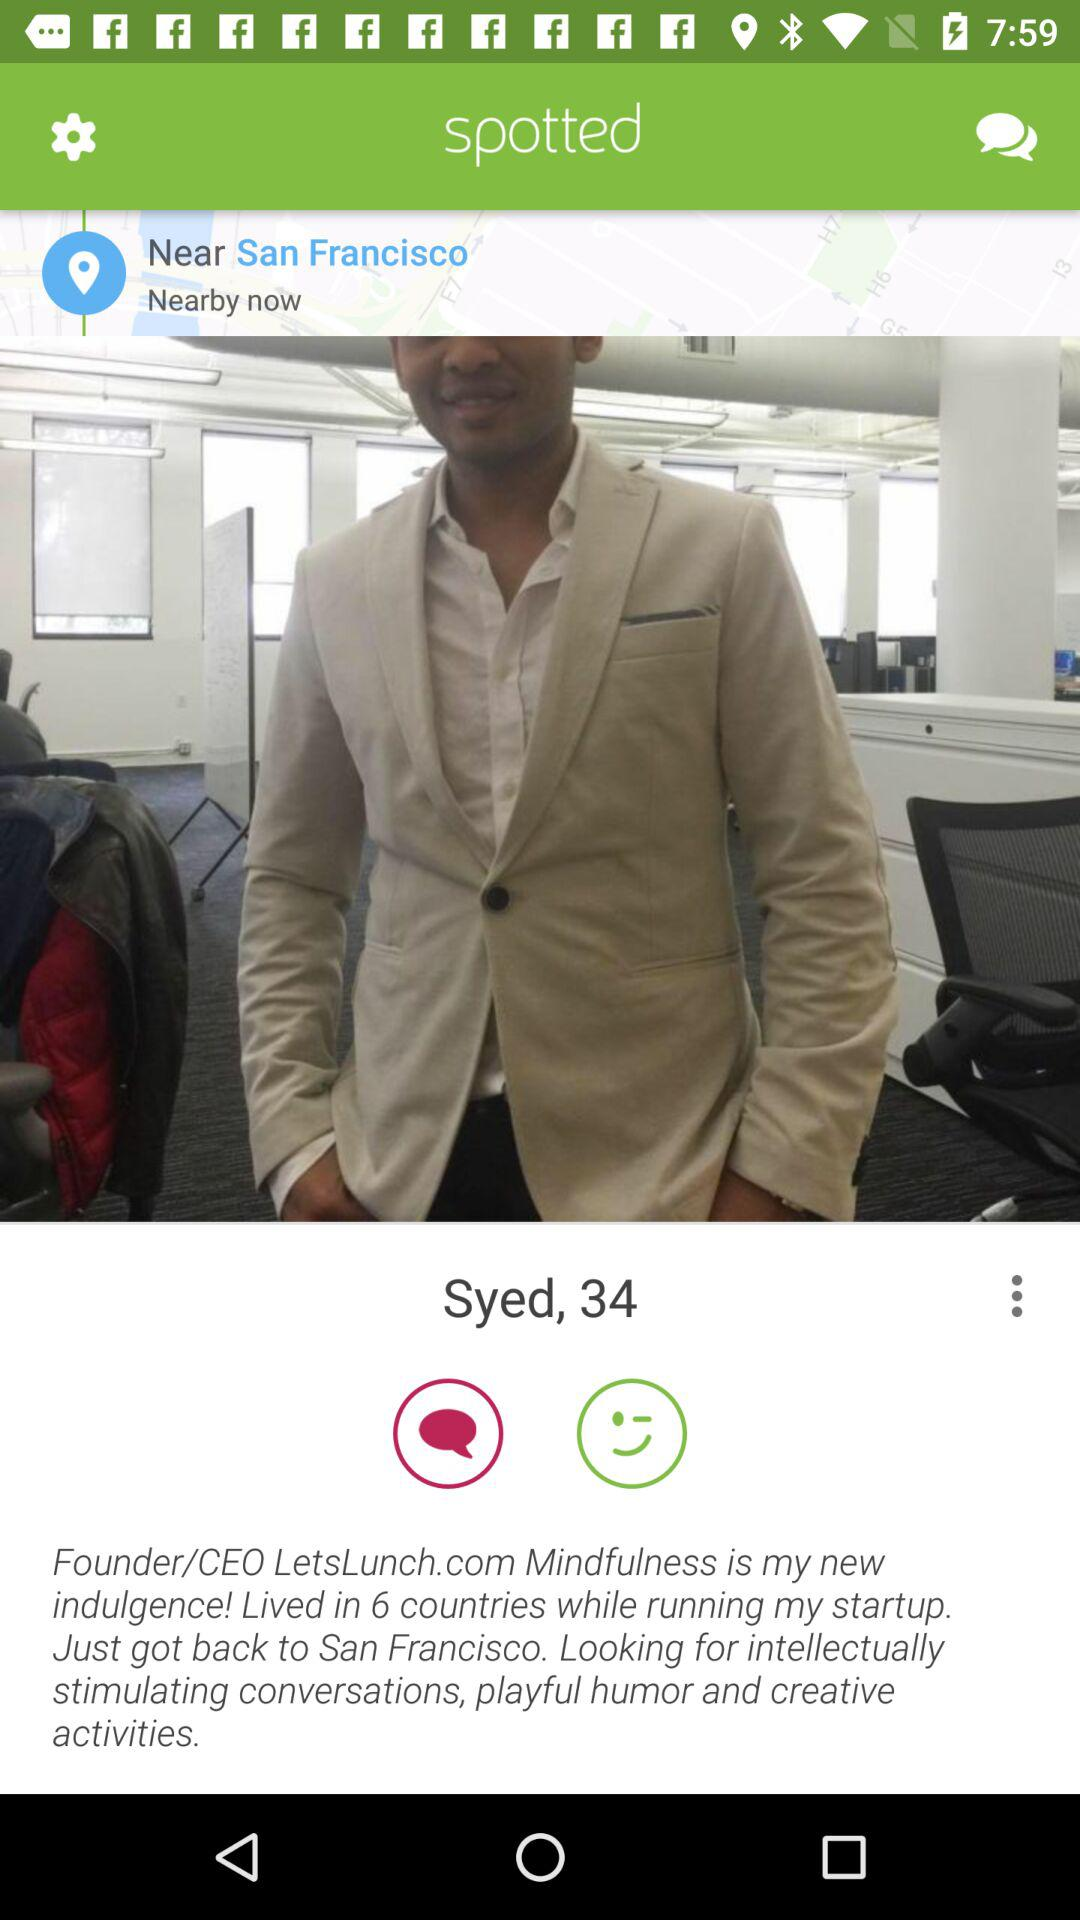What is the given location? The given location is San Francisco. 